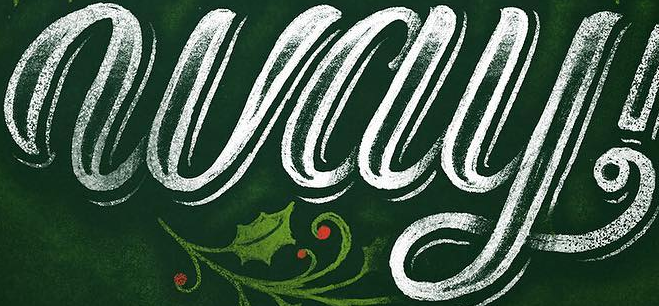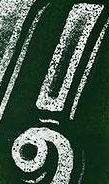Read the text content from these images in order, separated by a semicolon. way; ! 